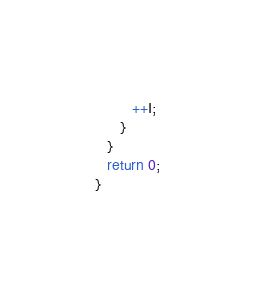Convert code to text. <code><loc_0><loc_0><loc_500><loc_500><_C++_>         ++I;
      }
   }
   return 0;
}

</code> 